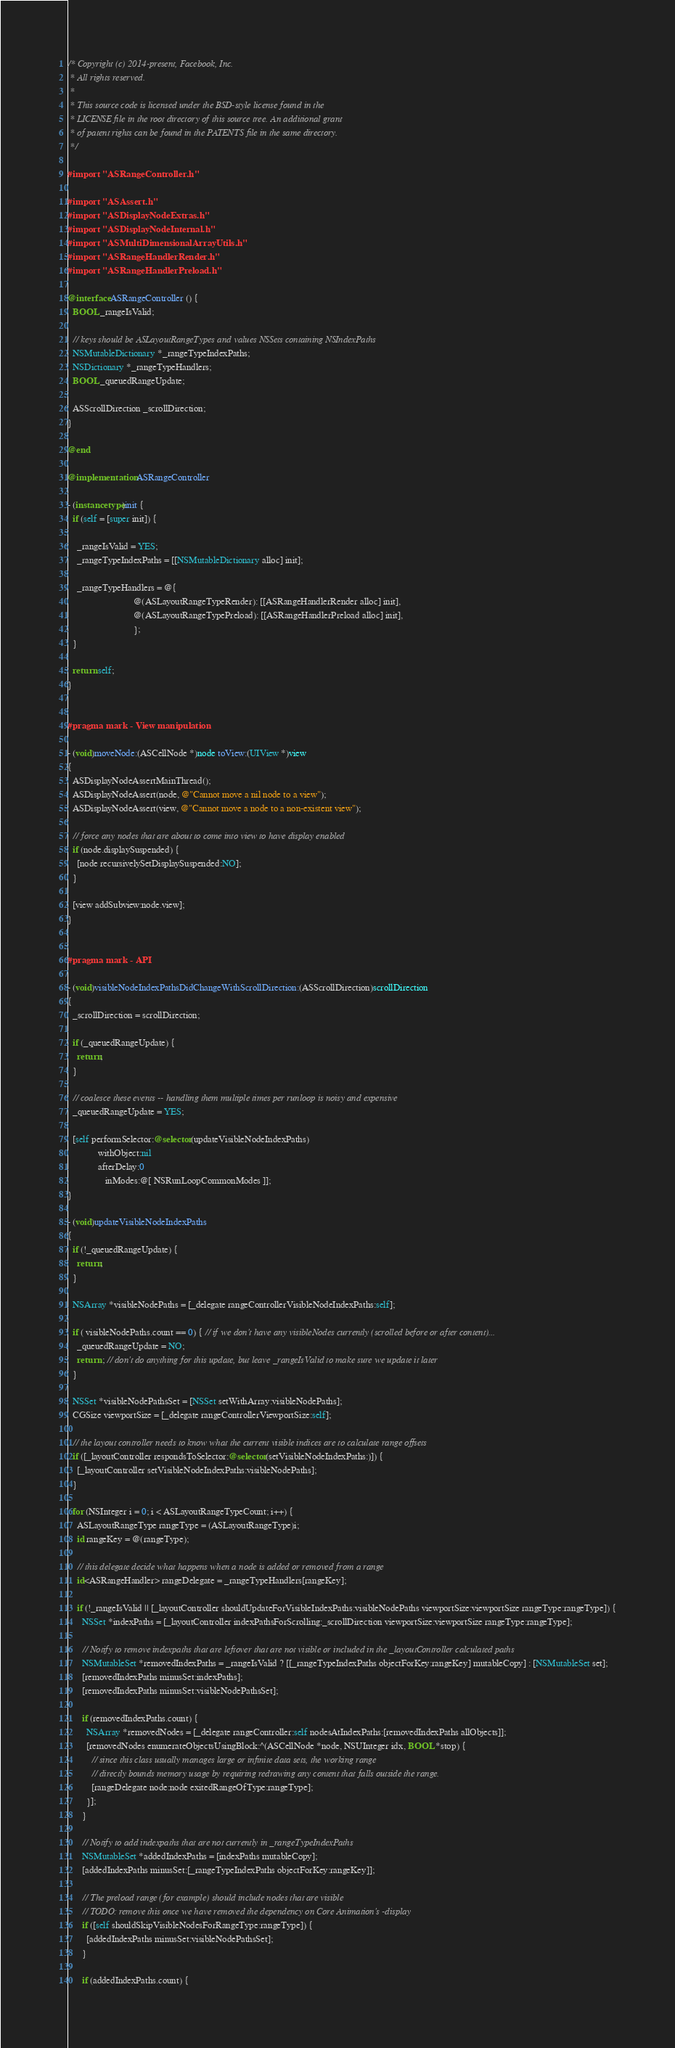<code> <loc_0><loc_0><loc_500><loc_500><_ObjectiveC_>/* Copyright (c) 2014-present, Facebook, Inc.
 * All rights reserved.
 *
 * This source code is licensed under the BSD-style license found in the
 * LICENSE file in the root directory of this source tree. An additional grant
 * of patent rights can be found in the PATENTS file in the same directory.
 */

#import "ASRangeController.h"

#import "ASAssert.h"
#import "ASDisplayNodeExtras.h"
#import "ASDisplayNodeInternal.h"
#import "ASMultiDimensionalArrayUtils.h"
#import "ASRangeHandlerRender.h"
#import "ASRangeHandlerPreload.h"

@interface ASRangeController () {
  BOOL _rangeIsValid;

  // keys should be ASLayoutRangeTypes and values NSSets containing NSIndexPaths
  NSMutableDictionary *_rangeTypeIndexPaths;
  NSDictionary *_rangeTypeHandlers;
  BOOL _queuedRangeUpdate;

  ASScrollDirection _scrollDirection;
}

@end

@implementation ASRangeController

- (instancetype)init {
  if (self = [super init]) {

    _rangeIsValid = YES;
    _rangeTypeIndexPaths = [[NSMutableDictionary alloc] init];

    _rangeTypeHandlers = @{
                            @(ASLayoutRangeTypeRender): [[ASRangeHandlerRender alloc] init],
                            @(ASLayoutRangeTypePreload): [[ASRangeHandlerPreload alloc] init],
                            };
  }

  return self;
}


#pragma mark - View manipulation

- (void)moveNode:(ASCellNode *)node toView:(UIView *)view
{
  ASDisplayNodeAssertMainThread();
  ASDisplayNodeAssert(node, @"Cannot move a nil node to a view");
  ASDisplayNodeAssert(view, @"Cannot move a node to a non-existent view");

  // force any nodes that are about to come into view to have display enabled
  if (node.displaySuspended) {
    [node recursivelySetDisplaySuspended:NO];
  }

  [view addSubview:node.view];
}


#pragma mark - API

- (void)visibleNodeIndexPathsDidChangeWithScrollDirection:(ASScrollDirection)scrollDirection
{
  _scrollDirection = scrollDirection;

  if (_queuedRangeUpdate) {
    return;
  }

  // coalesce these events -- handling them multiple times per runloop is noisy and expensive
  _queuedRangeUpdate = YES;

  [self performSelector:@selector(updateVisibleNodeIndexPaths)
             withObject:nil
             afterDelay:0
                inModes:@[ NSRunLoopCommonModes ]];
}

- (void)updateVisibleNodeIndexPaths
{
  if (!_queuedRangeUpdate) {
    return;
  }

  NSArray *visibleNodePaths = [_delegate rangeControllerVisibleNodeIndexPaths:self];

  if ( visibleNodePaths.count == 0) { // if we don't have any visibleNodes currently (scrolled before or after content)...
    _queuedRangeUpdate = NO;
    return ; // don't do anything for this update, but leave _rangeIsValid to make sure we update it later
  }

  NSSet *visibleNodePathsSet = [NSSet setWithArray:visibleNodePaths];
  CGSize viewportSize = [_delegate rangeControllerViewportSize:self];

  // the layout controller needs to know what the current visible indices are to calculate range offsets
  if ([_layoutController respondsToSelector:@selector(setVisibleNodeIndexPaths:)]) {
    [_layoutController setVisibleNodeIndexPaths:visibleNodePaths];
  }

  for (NSInteger i = 0; i < ASLayoutRangeTypeCount; i++) {
    ASLayoutRangeType rangeType = (ASLayoutRangeType)i;
    id rangeKey = @(rangeType);

    // this delegate decide what happens when a node is added or removed from a range
    id<ASRangeHandler> rangeDelegate = _rangeTypeHandlers[rangeKey];

    if (!_rangeIsValid || [_layoutController shouldUpdateForVisibleIndexPaths:visibleNodePaths viewportSize:viewportSize rangeType:rangeType]) {
      NSSet *indexPaths = [_layoutController indexPathsForScrolling:_scrollDirection viewportSize:viewportSize rangeType:rangeType];

      // Notify to remove indexpaths that are leftover that are not visible or included in the _layoutController calculated paths
      NSMutableSet *removedIndexPaths = _rangeIsValid ? [[_rangeTypeIndexPaths objectForKey:rangeKey] mutableCopy] : [NSMutableSet set];
      [removedIndexPaths minusSet:indexPaths];
      [removedIndexPaths minusSet:visibleNodePathsSet];

      if (removedIndexPaths.count) {
        NSArray *removedNodes = [_delegate rangeController:self nodesAtIndexPaths:[removedIndexPaths allObjects]];
        [removedNodes enumerateObjectsUsingBlock:^(ASCellNode *node, NSUInteger idx, BOOL *stop) {
          // since this class usually manages large or infinite data sets, the working range
          // directly bounds memory usage by requiring redrawing any content that falls outside the range.
          [rangeDelegate node:node exitedRangeOfType:rangeType];
        }];
      }

      // Notify to add indexpaths that are not currently in _rangeTypeIndexPaths
      NSMutableSet *addedIndexPaths = [indexPaths mutableCopy];
      [addedIndexPaths minusSet:[_rangeTypeIndexPaths objectForKey:rangeKey]];

      // The preload range (for example) should include nodes that are visible
      // TODO: remove this once we have removed the dependency on Core Animation's -display
      if ([self shouldSkipVisibleNodesForRangeType:rangeType]) {
        [addedIndexPaths minusSet:visibleNodePathsSet];
      }
      
      if (addedIndexPaths.count) {</code> 